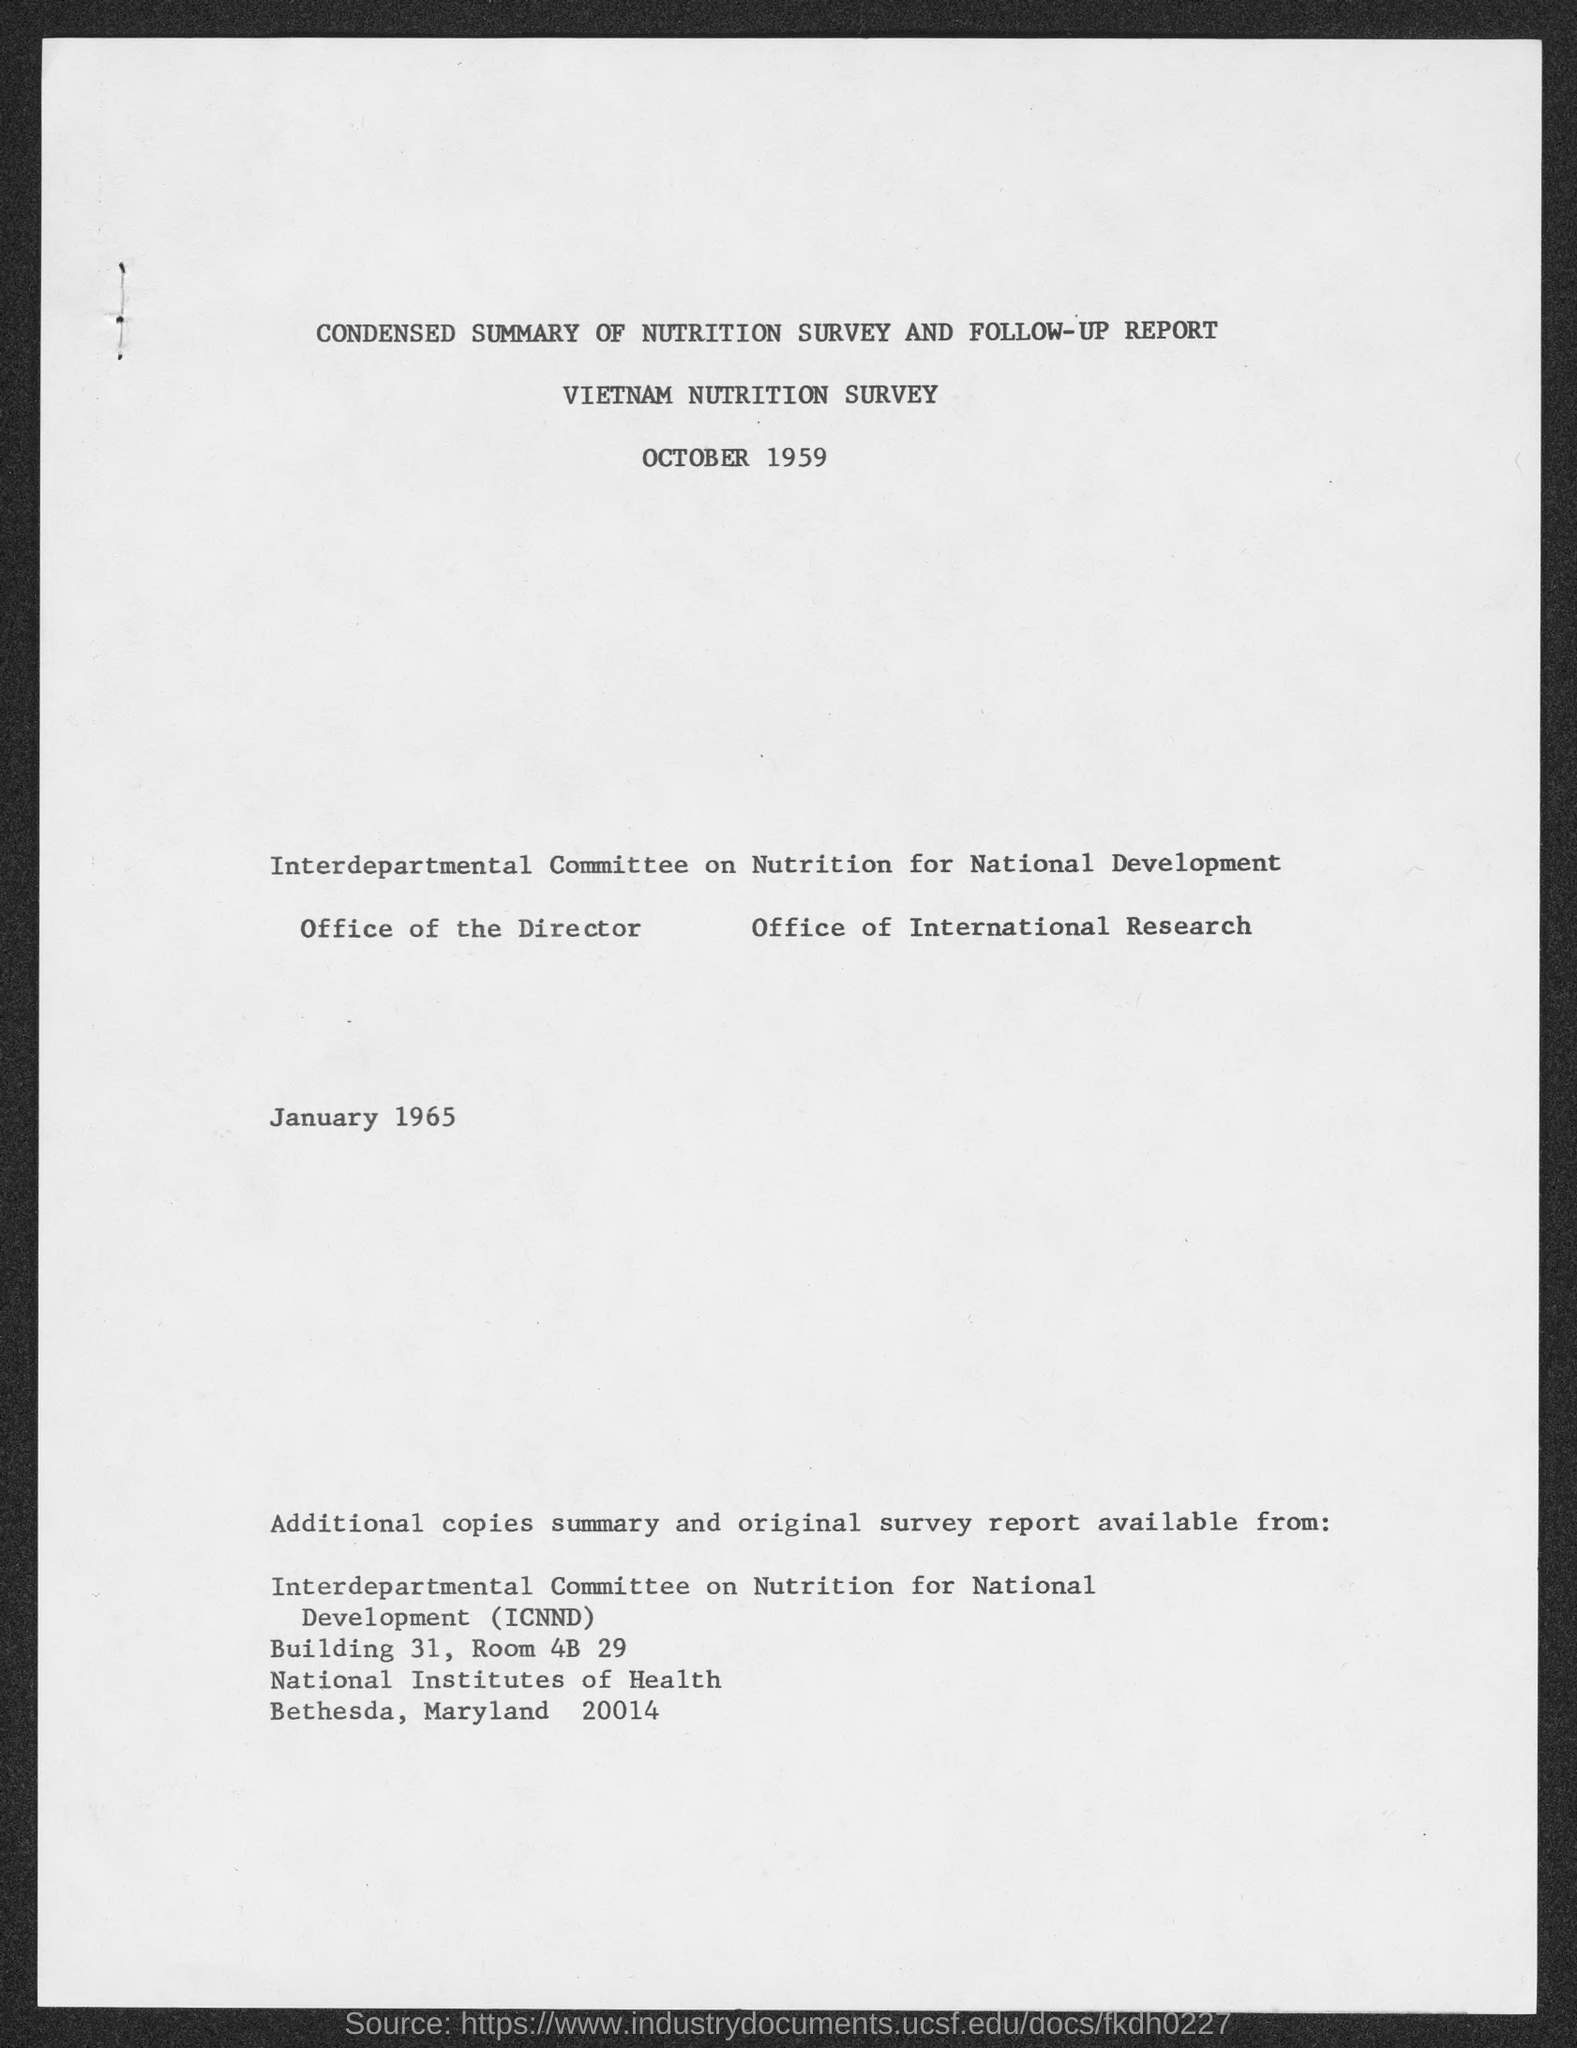Point out several critical features in this image. The name of the survey is the Vietnam Nutrition Survey. The Interdepartmental Committee on Nutrition for National Development, commonly referred to as ICNND, is a committee responsible for promoting and coordinating efforts related to nutrition and food security in our country. The document in question is titled 'What is the document title?', it is a condensed summary of the nutrition survey and follow-up report. On October 1959, the Nutrition Survey was conducted. 